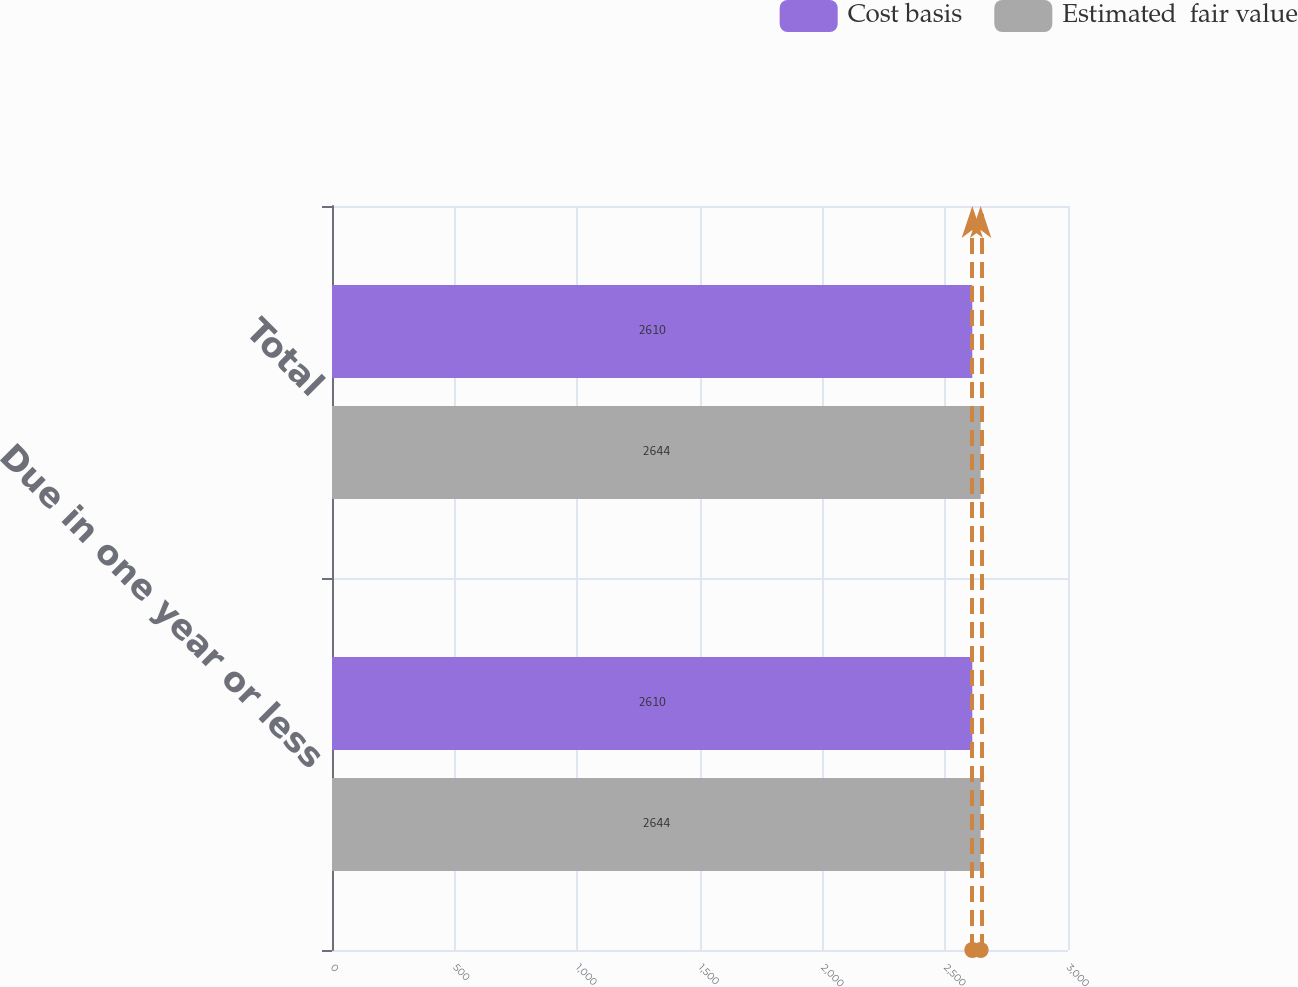<chart> <loc_0><loc_0><loc_500><loc_500><stacked_bar_chart><ecel><fcel>Due in one year or less<fcel>Total<nl><fcel>Cost basis<fcel>2610<fcel>2610<nl><fcel>Estimated  fair value<fcel>2644<fcel>2644<nl></chart> 